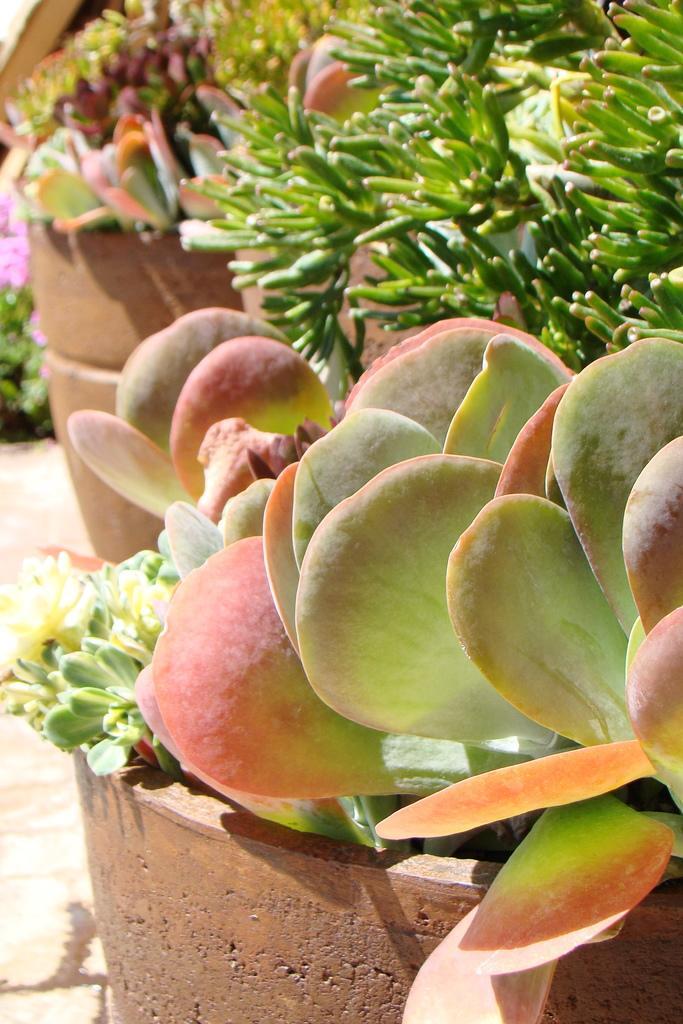Can you describe this image briefly? In this picture I can see some potted plants are placed. 